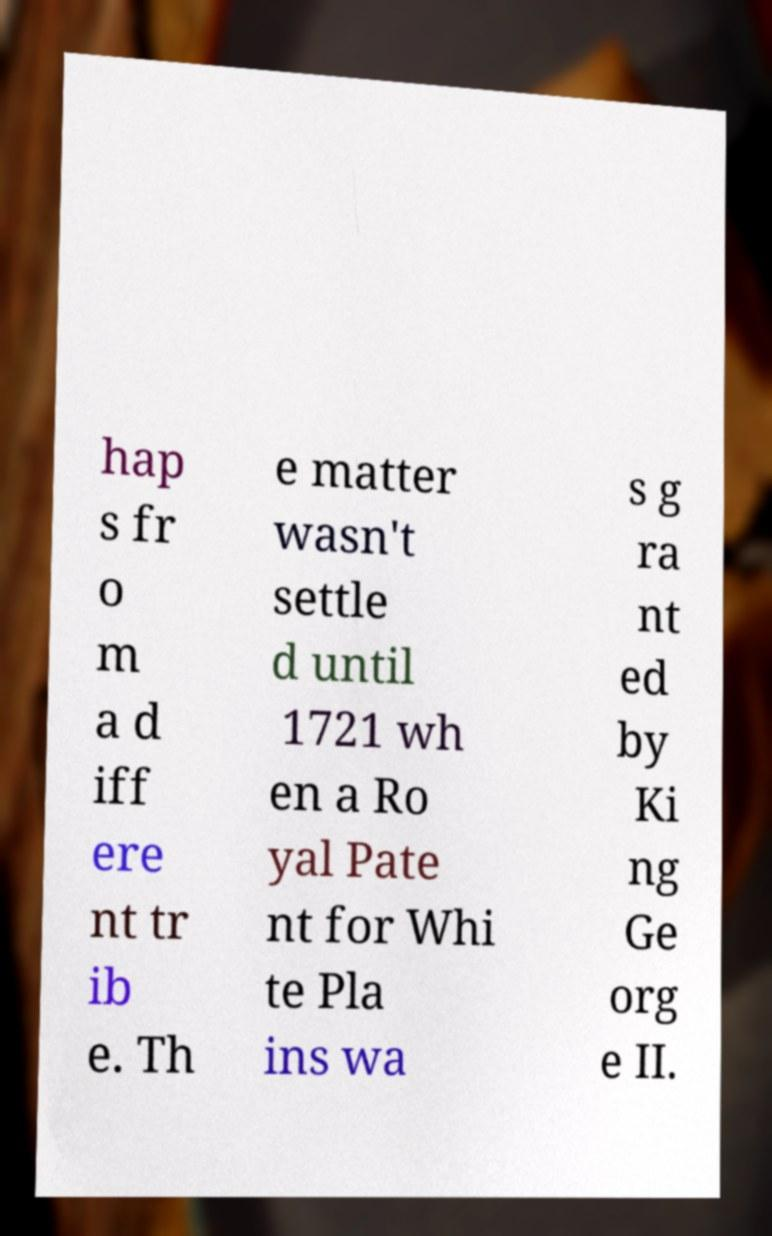There's text embedded in this image that I need extracted. Can you transcribe it verbatim? hap s fr o m a d iff ere nt tr ib e. Th e matter wasn't settle d until 1721 wh en a Ro yal Pate nt for Whi te Pla ins wa s g ra nt ed by Ki ng Ge org e II. 